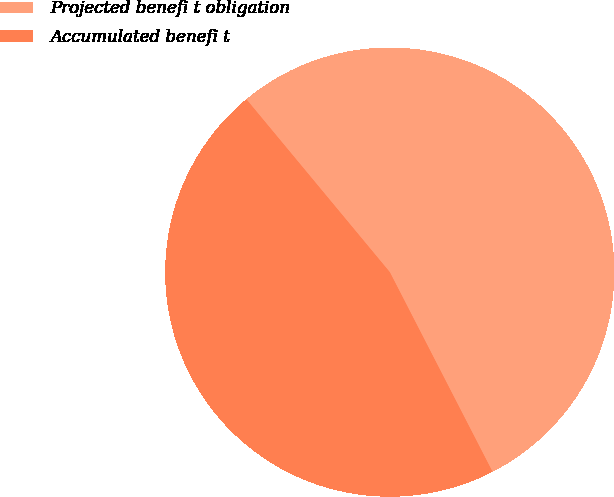Convert chart to OTSL. <chart><loc_0><loc_0><loc_500><loc_500><pie_chart><fcel>Projected benefi t obligation<fcel>Accumulated benefi t<nl><fcel>53.46%<fcel>46.54%<nl></chart> 